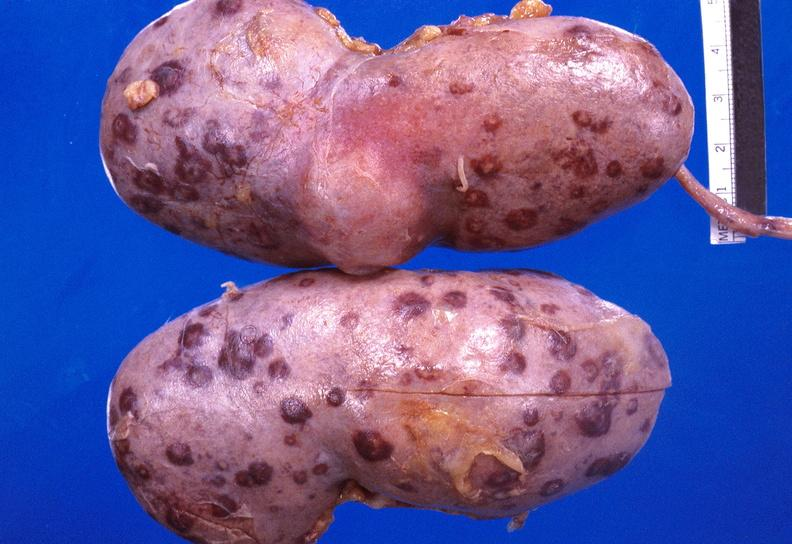does so-called median bar show kidney candida abscesses from patient with acute myelogenous leukemia?
Answer the question using a single word or phrase. No 